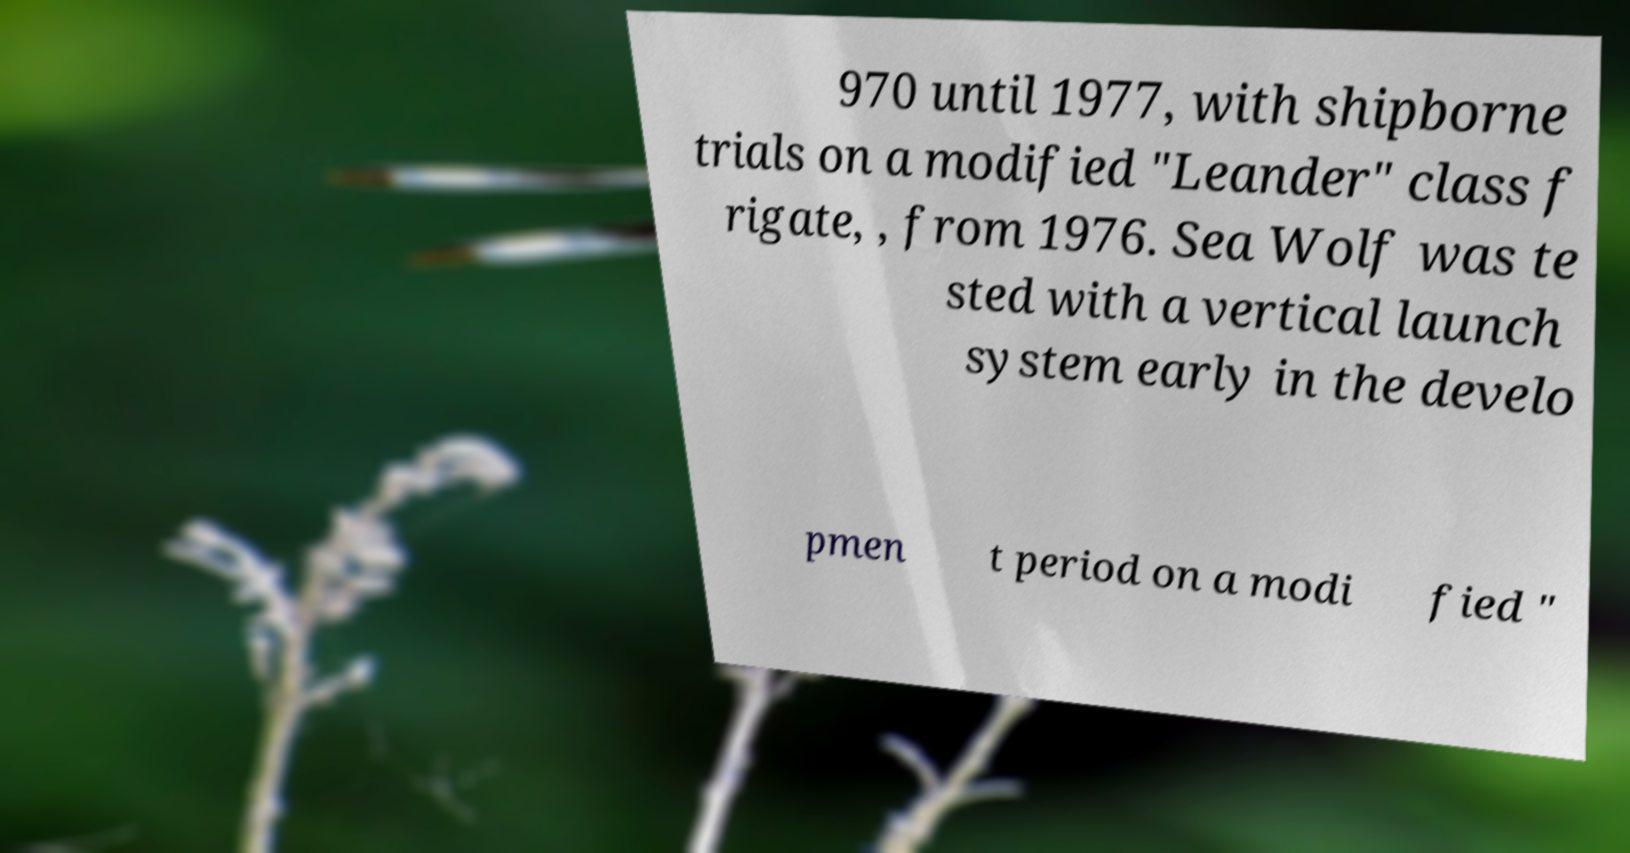Please identify and transcribe the text found in this image. 970 until 1977, with shipborne trials on a modified "Leander" class f rigate, , from 1976. Sea Wolf was te sted with a vertical launch system early in the develo pmen t period on a modi fied " 